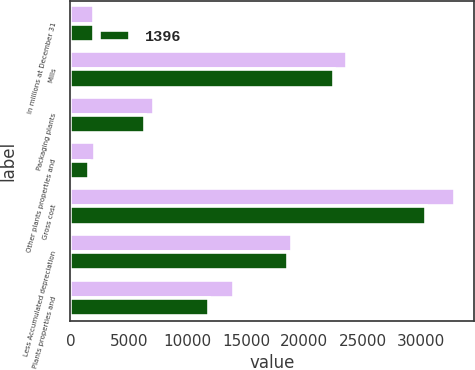Convert chart to OTSL. <chart><loc_0><loc_0><loc_500><loc_500><stacked_bar_chart><ecel><fcel>In millions at December 31<fcel>Mills<fcel>Packaging plants<fcel>Other plants properties and<fcel>Gross cost<fcel>Less Accumulated depreciation<fcel>Plants properties and<nl><fcel>nan<fcel>2012<fcel>23625<fcel>7184<fcel>2074<fcel>32883<fcel>18934<fcel>13949<nl><fcel>1396<fcel>2011<fcel>22494<fcel>6358<fcel>1556<fcel>30408<fcel>18591<fcel>11817<nl></chart> 